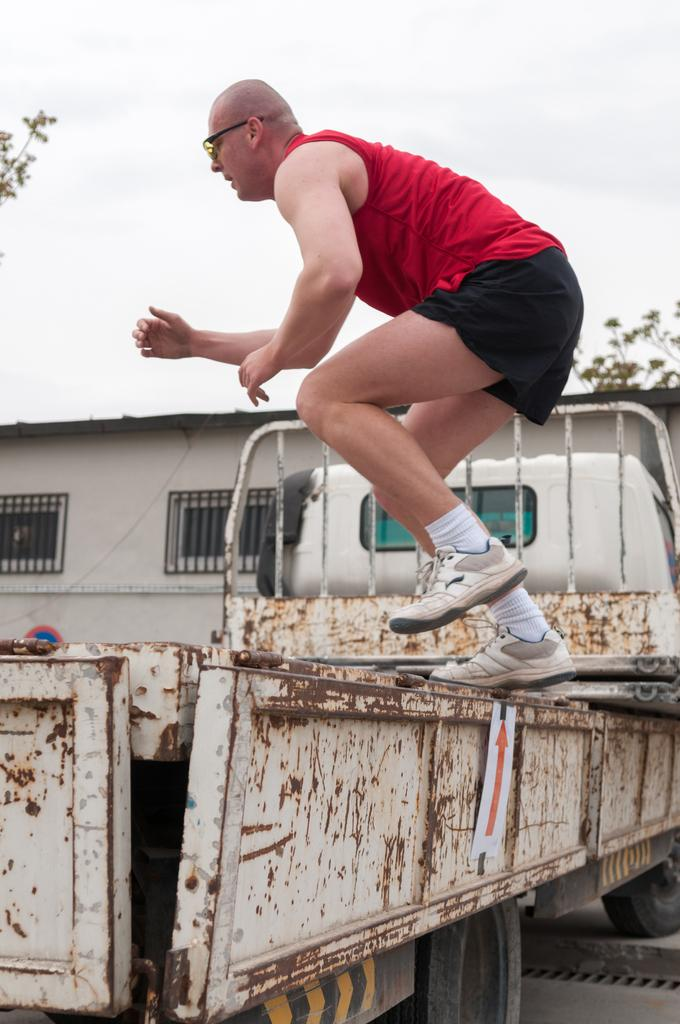What is there is a man standing on a vehicle in the foreground of the image. What is he doing? The man is standing on a vehicle in the foreground of the image. What can be seen in the background of the image? There is a building and trees in the background of the image. What is visible in the sky in the image? There are clouds visible in the image. How does the baby contribute to the vehicle's expansion in the image? There is no baby present in the image, and the vehicle's expansion is not mentioned or depicted. 